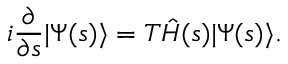Convert formula to latex. <formula><loc_0><loc_0><loc_500><loc_500>i \frac { \partial } { \partial s } | \Psi ( s ) \rangle = T \hat { H } ( s ) | \Psi ( s ) \rangle .</formula> 